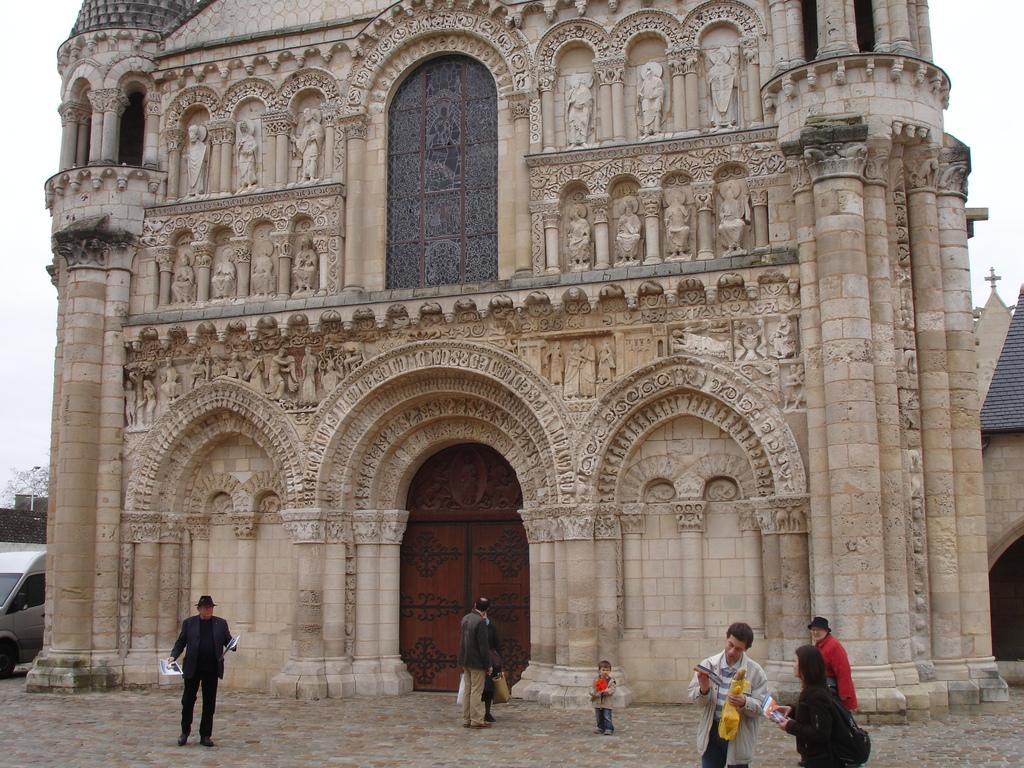What is the main structure in the center of the image? There is a building in the center of the image. What feature of the building is in the center of the image? There is a door in the center of the image. What can be seen at the bottom of the image? There is a car and persons at the bottom of the image. What is visible in the background of the image? The sky is visible in the background of the image. How many smiles can be seen on the building in the image? There are no smiles visible on the building in the image. 